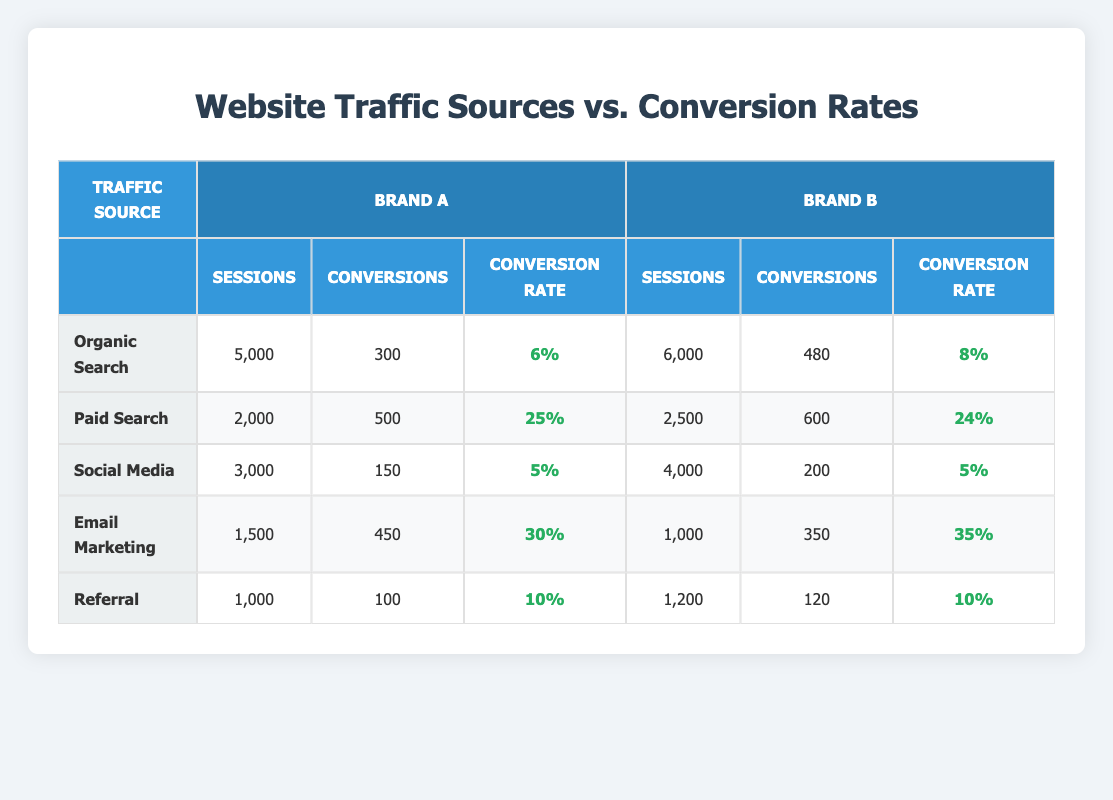What is the conversion rate for Email Marketing for Brand A? The conversion rate for Email Marketing for Brand A is listed in the table under the relevant row. It shows a conversion rate of 30%.
Answer: 30% How many sessions did Brand B receive from Paid Search? In the table, the row for Paid Search under Brand B shows the number of sessions is 2,500.
Answer: 2,500 Which traffic source had the highest conversion rate for Brand A? Checking the conversion rates for each traffic source in Brand A, Email Marketing has the highest conversion rate at 30%.
Answer: Email Marketing What is the total number of sessions from all traffic sources for Brand A? The total number of sessions is the sum of all sessions for Brand A: 5000 + 2000 + 3000 + 1500 + 1000 = 12500.
Answer: 12,500 Is it true that Organic Search has a higher conversion rate for Brand A compared to Brand B? Looking at the conversion rates for Organic Search, Brand A has a conversion rate of 6%, while Brand B has 8%. Thus, the statement is false.
Answer: No What is the difference in conversion rates between Email Marketing for Brand A and Brand B? The conversion rate for Email Marketing for Brand A is 30%, and for Brand B, it is 35%. The difference is calculated as 35% - 30% = 5%.
Answer: 5% Which traffic source had the lowest number of conversions for Brand B? By checking the conversions for each traffic source for Brand B, Social Media has the lowest conversions at 200.
Answer: Social Media How many total conversions were made from Referral traffic sources across both brands? Brand A's conversions from Referral is 100, while Brand B's is 120. Total conversions from both brands = 100 + 120 = 220.
Answer: 220 What is the average conversion rate for all traffic sources in Brand A? The conversion rates for Brand A are 6%, 25%, 5%, 30%, and 10%. The average is calculated as (6 + 25 + 5 + 30 + 10) / 5 = 76 / 5 = 15.2%.
Answer: 15.2% 